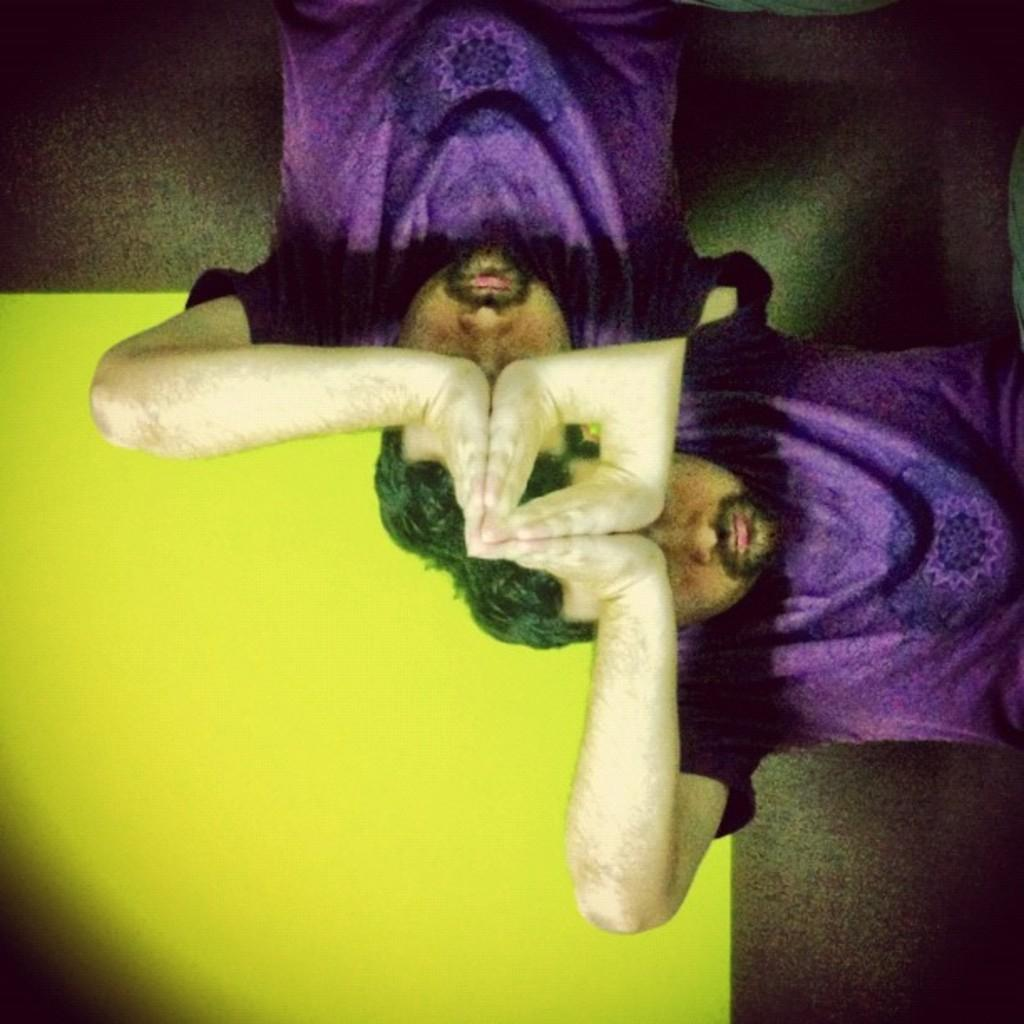What is the main subject of the image? The main subject of the image is a man. What is the man wearing in the image? The man is wearing a purple t-shirt in the image. What is the man doing in the image? The man is praying in the image. How would you describe the nature of the image? The image is graphic in nature. How many eggs are visible in the image? There are no eggs present in the image. What type of pizzas can be seen in the image? There are no pizzas present in the image. 